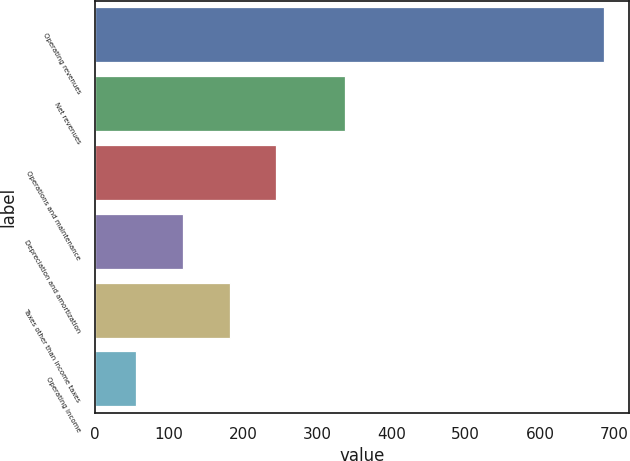<chart> <loc_0><loc_0><loc_500><loc_500><bar_chart><fcel>Operating revenues<fcel>Net revenues<fcel>Operations and maintenance<fcel>Depreciation and amortization<fcel>Taxes other than income taxes<fcel>Operating income<nl><fcel>686<fcel>337<fcel>245<fcel>119<fcel>182<fcel>56<nl></chart> 